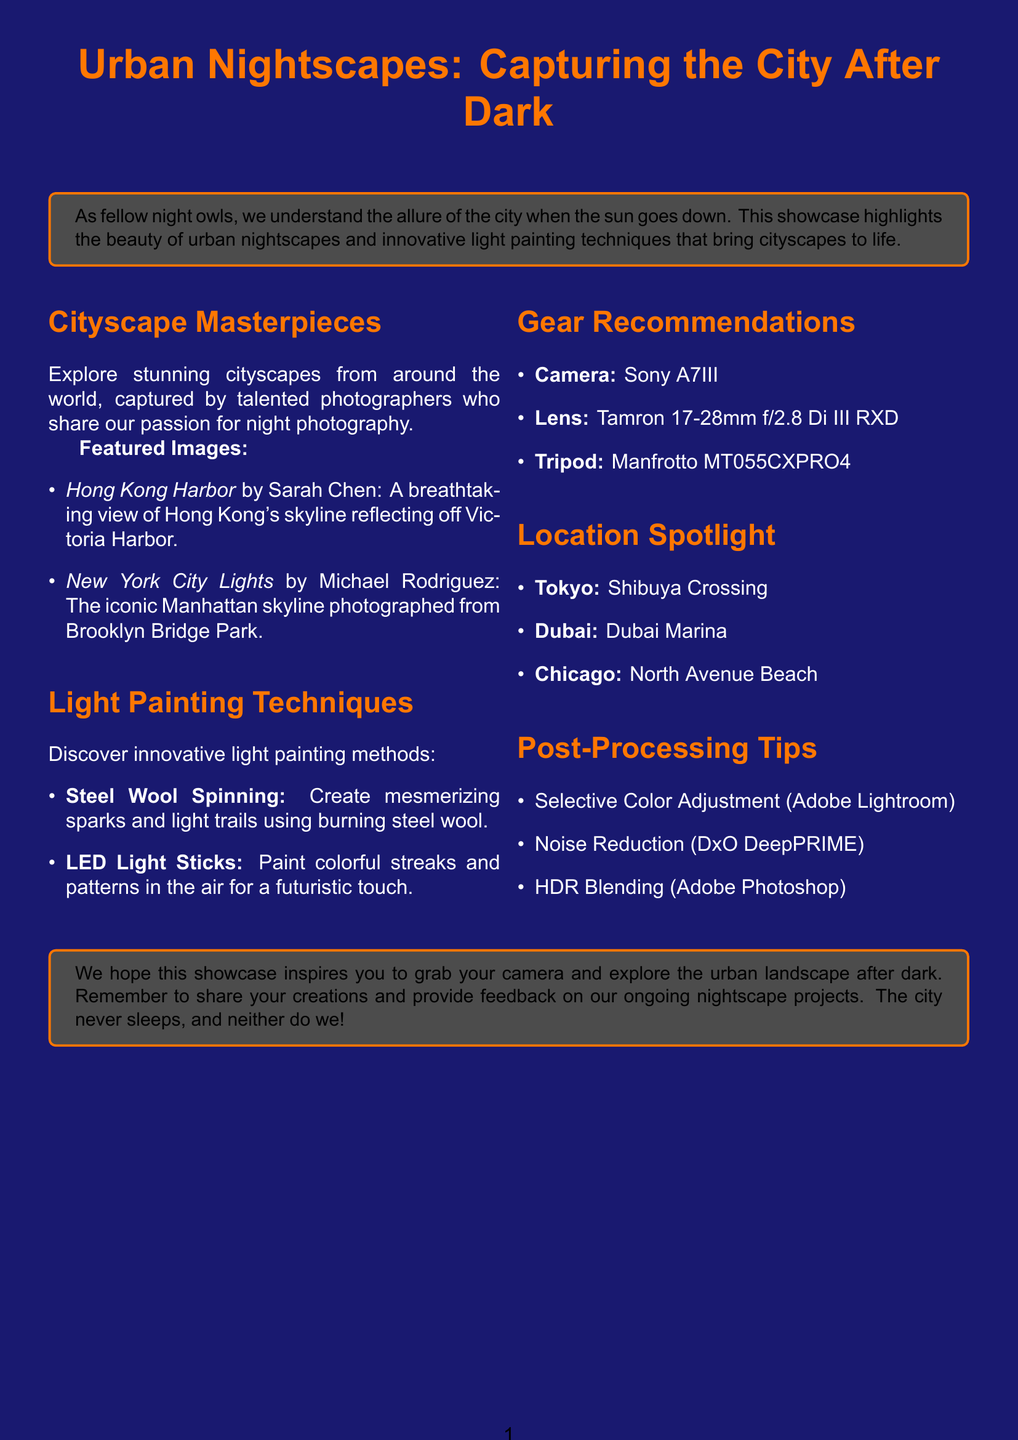What is the title of the brochure? The title is stated at the beginning of the document, serving as the main focus of the content.
Answer: Urban Nightscapes: Capturing the City After Dark Who photographed "Hong Kong Harbor"? The photographer's name is mentioned alongside the image title in the featured images section.
Answer: Sarah Chen What technique involves using burning steel wool? The content section outlines various light painting techniques, identifying the specific actions associated with each.
Answer: Steel Wool Spinning Which city is spotlighted for Shibuya Crossing? The location spotlight section lists cities recognized for their unique photography spots, highlighting the specific place within the city.
Answer: Tokyo, Japan What is the recommended camera for night photography? The gear recommendations section offers essential equipment, clearly listing each recommended item for capturing nightscapes.
Answer: Sony A7III What post-processing software is suggested for noise reduction? The post-processing tips section specifies software tools recommended for enhancing photographs, indicating their intended use.
Answer: DxO DeepPRIME How many featured images are listed in the Cityscape Masterpieces section? The document illustrates the content structure, providing explicit mentions of the featured images under the respective section.
Answer: 2 What color is used in the background of the document? The document specifies the design elements, including colors used in background and text layouts.
Answer: Night blue Which city has a description emphasizing modern architecture? The location spotlight section mentions various cities, and each description highlights a key characteristic relevant to photography.
Answer: Dubai, UAE 